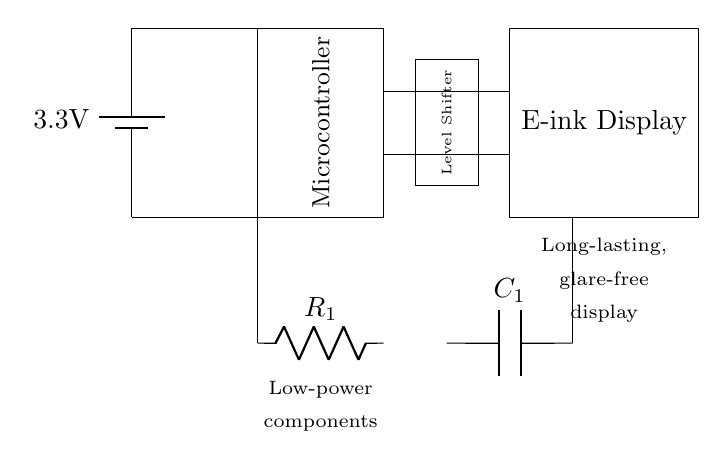What is the voltage of the power supply? The voltage is indicated on the battery symbol in the circuit and is labeled as three point three volts.
Answer: three point three volts What is the primary function of the microcontroller in this circuit? The microcontroller acts as the control unit, facilitating communication between the input (like sensors) and output devices (like the display).
Answer: control unit How many low-power components are shown in the diagram? There are two low-power components specified in the diagram, which are a resistor and a capacitor.
Answer: two What is the role of the level shifter in this circuit? The level shifter is necessary for converting voltage levels between devices, ensuring compatibility between the microcontroller and the e-ink display.
Answer: voltage level conversion What type of display is used in this circuit? The diagram specifies the use of an e-ink display, which is known for its low power consumption and glare-free reading capabilities.
Answer: e-ink display Which component provides the actual power to the circuit? The battery provides the necessary power supply for the entire circuit, indicated as having a voltage output.
Answer: battery At what point is the voltage input connected in the circuit? The voltage input is connected at the battery's positive terminal, which supplies power to the rest of the circuit.
Answer: battery positive terminal 